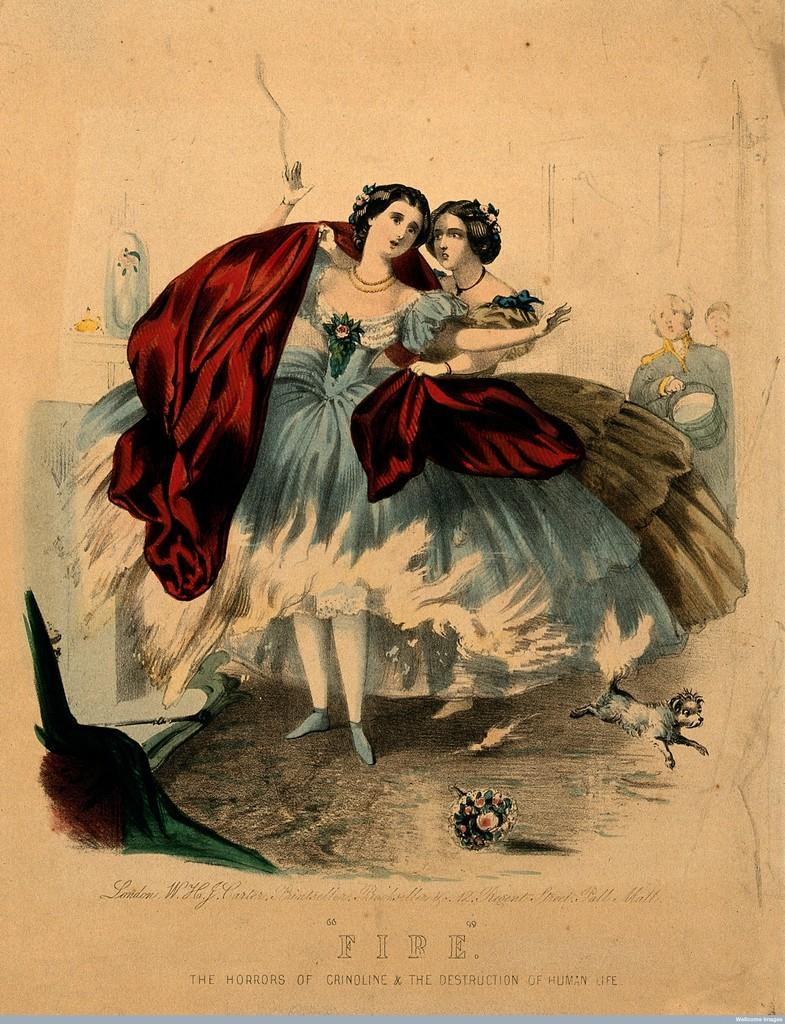What is featured in the image along with people? There is a poster, a dog, a flower bouquet, and various objects in the image. Can you describe the poster in the image? The poster is a part of the image, but no specific details about the poster are provided in the facts. What type of animal is present in the image? There is a dog in the image. What is located at the bottom of the image? There is text at the bottom of the image. Reasoning: Let' Let's think step by step in order to produce the conversation. We start by identifying the main subjects and objects in the image based on the provided facts. We then formulate questions that focus on the location and characteristics of these subjects and objects, ensuring that each question can be answered definitively with the information given. We avoid yes/no questions and ensure that the language is simple and clear. Absurd Question/Answer: Where is the crate located in the image? There is no crate present in the image. Can you tell me what type of degree is mentioned in the text at the bottom of the image? There is no mention of a degree in the text at the bottom of the image. 